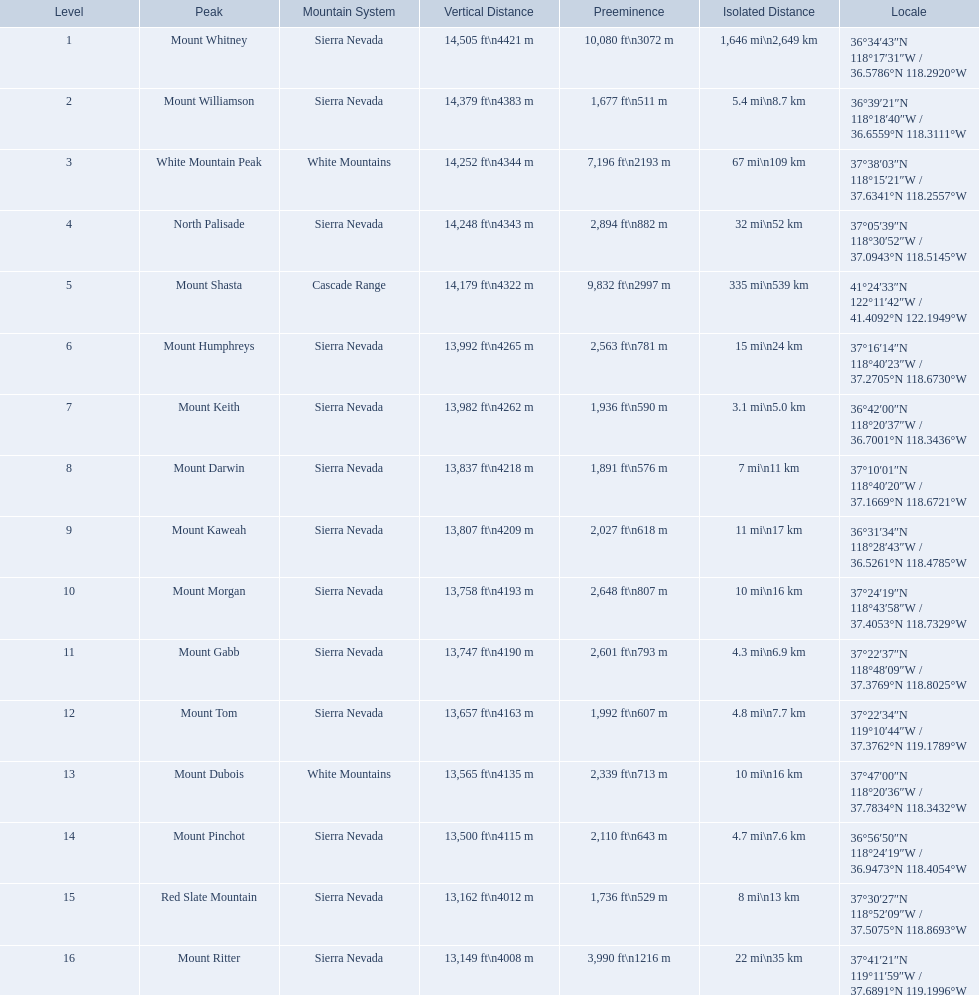What are all of the mountain peaks? Mount Whitney, Mount Williamson, White Mountain Peak, North Palisade, Mount Shasta, Mount Humphreys, Mount Keith, Mount Darwin, Mount Kaweah, Mount Morgan, Mount Gabb, Mount Tom, Mount Dubois, Mount Pinchot, Red Slate Mountain, Mount Ritter. In what ranges are they? Sierra Nevada, Sierra Nevada, White Mountains, Sierra Nevada, Cascade Range, Sierra Nevada, Sierra Nevada, Sierra Nevada, Sierra Nevada, Sierra Nevada, Sierra Nevada, Sierra Nevada, White Mountains, Sierra Nevada, Sierra Nevada, Sierra Nevada. Which peak is in the cascade range? Mount Shasta. 